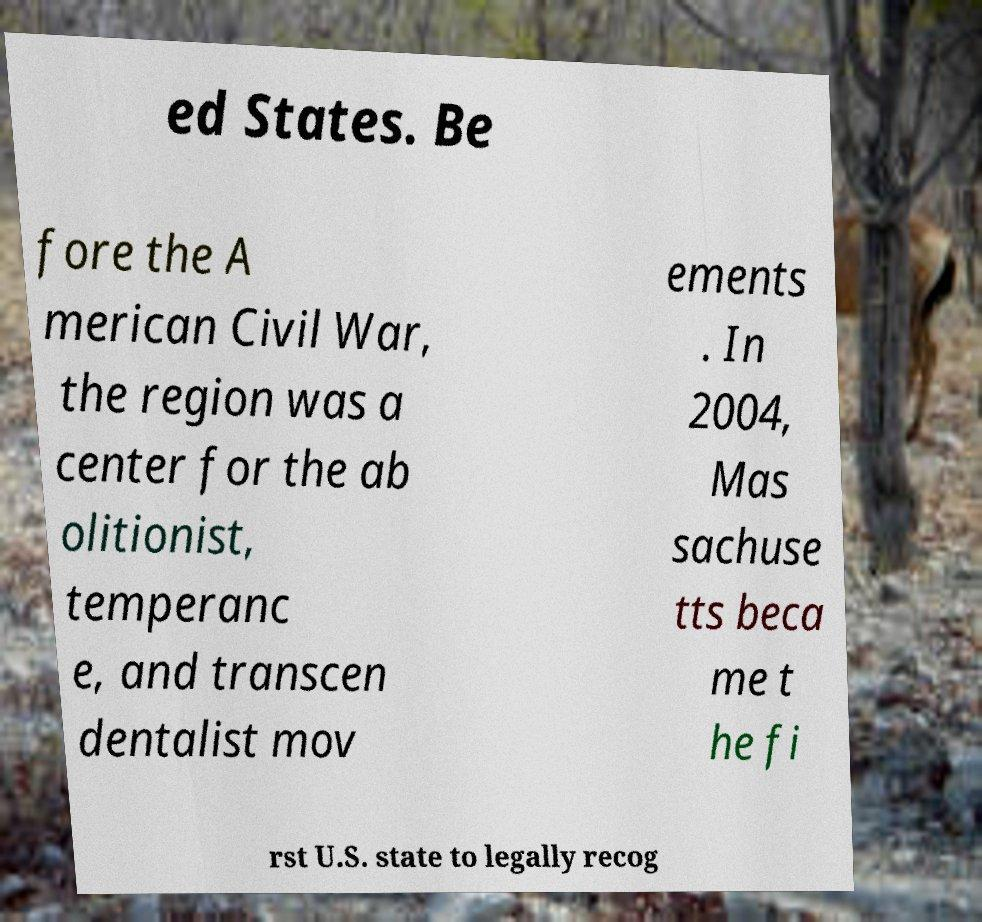Please identify and transcribe the text found in this image. ed States. Be fore the A merican Civil War, the region was a center for the ab olitionist, temperanc e, and transcen dentalist mov ements . In 2004, Mas sachuse tts beca me t he fi rst U.S. state to legally recog 